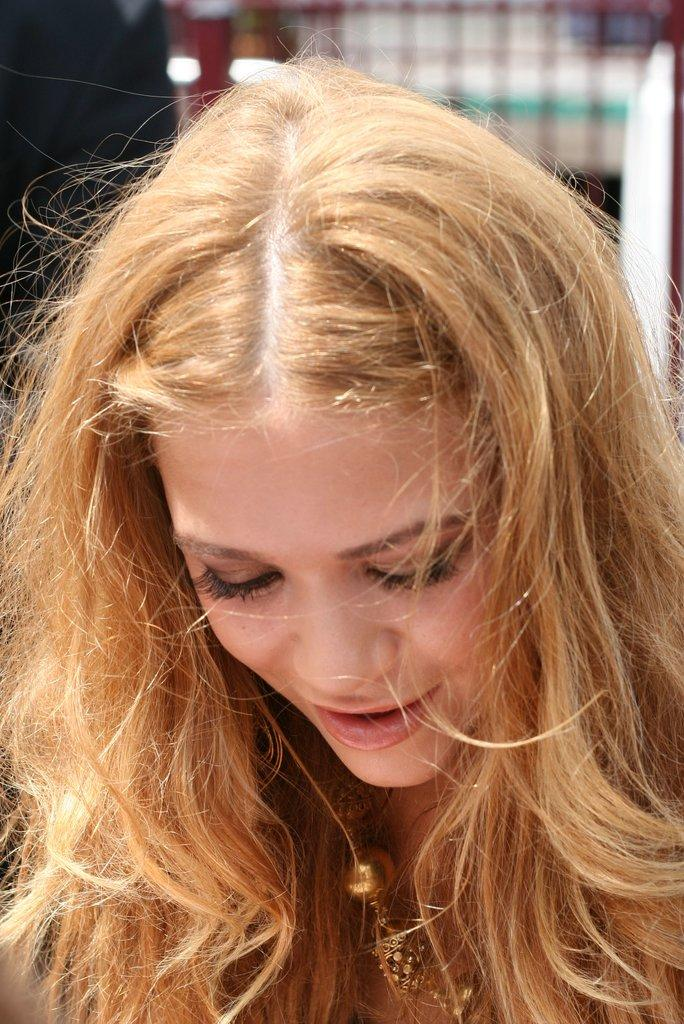What is the main subject in the foreground of the image? There is a woman in the foreground of the image. Can you describe the woman's appearance? The woman has blonde hair. What can be observed about the background of the image? The background of the image is blurred. What type of music can be heard coming from the circle in the image? There is no circle or music present in the image. 